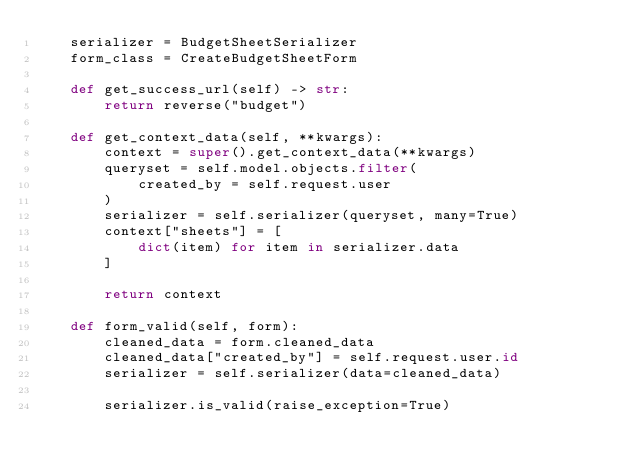<code> <loc_0><loc_0><loc_500><loc_500><_Python_>    serializer = BudgetSheetSerializer
    form_class = CreateBudgetSheetForm
    
    def get_success_url(self) -> str:
        return reverse("budget")

    def get_context_data(self, **kwargs):
        context = super().get_context_data(**kwargs)
        queryset = self.model.objects.filter(
            created_by = self.request.user
        )
        serializer = self.serializer(queryset, many=True)
        context["sheets"] = [
            dict(item) for item in serializer.data
        ]

        return context

    def form_valid(self, form):
        cleaned_data = form.cleaned_data
        cleaned_data["created_by"] = self.request.user.id
        serializer = self.serializer(data=cleaned_data)

        serializer.is_valid(raise_exception=True)</code> 